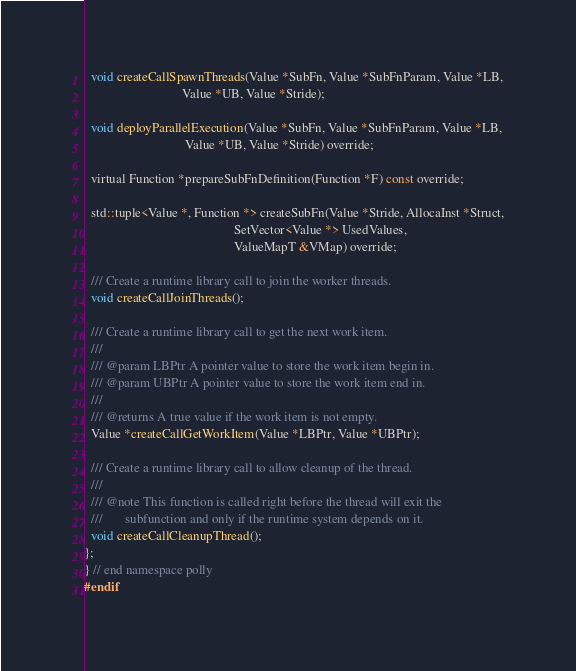<code> <loc_0><loc_0><loc_500><loc_500><_C_>  void createCallSpawnThreads(Value *SubFn, Value *SubFnParam, Value *LB,
                              Value *UB, Value *Stride);

  void deployParallelExecution(Value *SubFn, Value *SubFnParam, Value *LB,
                               Value *UB, Value *Stride) override;

  virtual Function *prepareSubFnDefinition(Function *F) const override;

  std::tuple<Value *, Function *> createSubFn(Value *Stride, AllocaInst *Struct,
                                              SetVector<Value *> UsedValues,
                                              ValueMapT &VMap) override;

  /// Create a runtime library call to join the worker threads.
  void createCallJoinThreads();

  /// Create a runtime library call to get the next work item.
  ///
  /// @param LBPtr A pointer value to store the work item begin in.
  /// @param UBPtr A pointer value to store the work item end in.
  ///
  /// @returns A true value if the work item is not empty.
  Value *createCallGetWorkItem(Value *LBPtr, Value *UBPtr);

  /// Create a runtime library call to allow cleanup of the thread.
  ///
  /// @note This function is called right before the thread will exit the
  ///       subfunction and only if the runtime system depends on it.
  void createCallCleanupThread();
};
} // end namespace polly
#endif
</code> 